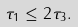Convert formula to latex. <formula><loc_0><loc_0><loc_500><loc_500>\tau _ { 1 } \leq 2 \tau _ { 3 } .</formula> 